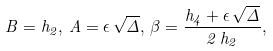<formula> <loc_0><loc_0><loc_500><loc_500>B = h _ { 2 } , \, A = \epsilon \, \sqrt { \Delta } , \, \beta = \frac { h _ { 4 } + \epsilon \, \sqrt { \Delta } } { 2 \, h _ { 2 } } ,</formula> 